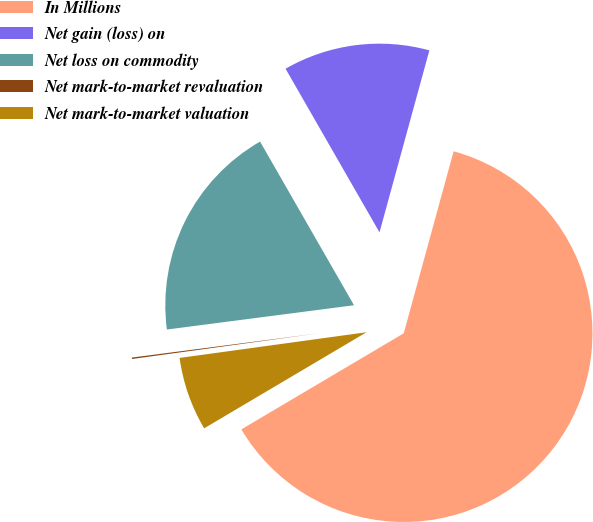Convert chart to OTSL. <chart><loc_0><loc_0><loc_500><loc_500><pie_chart><fcel>In Millions<fcel>Net gain (loss) on<fcel>Net loss on commodity<fcel>Net mark-to-market revaluation<fcel>Net mark-to-market valuation<nl><fcel>62.24%<fcel>12.55%<fcel>18.76%<fcel>0.12%<fcel>6.33%<nl></chart> 